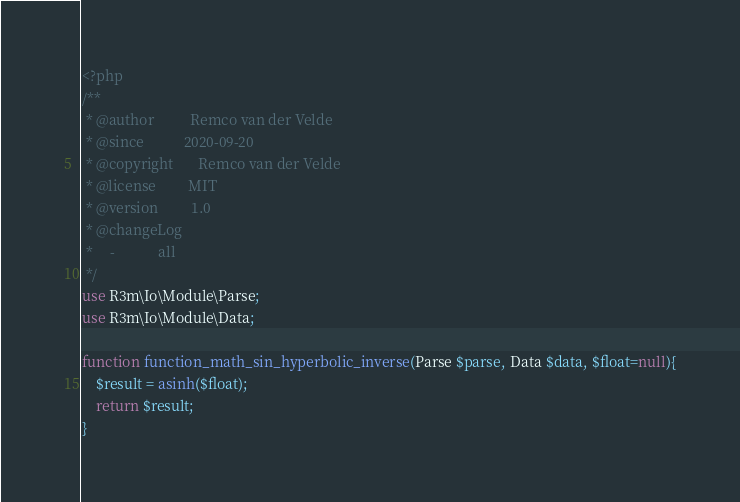<code> <loc_0><loc_0><loc_500><loc_500><_PHP_><?php
/**
 * @author          Remco van der Velde
 * @since           2020-09-20
 * @copyright       Remco van der Velde
 * @license         MIT
 * @version         1.0
 * @changeLog
 *     -            all
 */
use R3m\Io\Module\Parse;
use R3m\Io\Module\Data;

function function_math_sin_hyperbolic_inverse(Parse $parse, Data $data, $float=null){
    $result = asinh($float);
    return $result;
}
</code> 